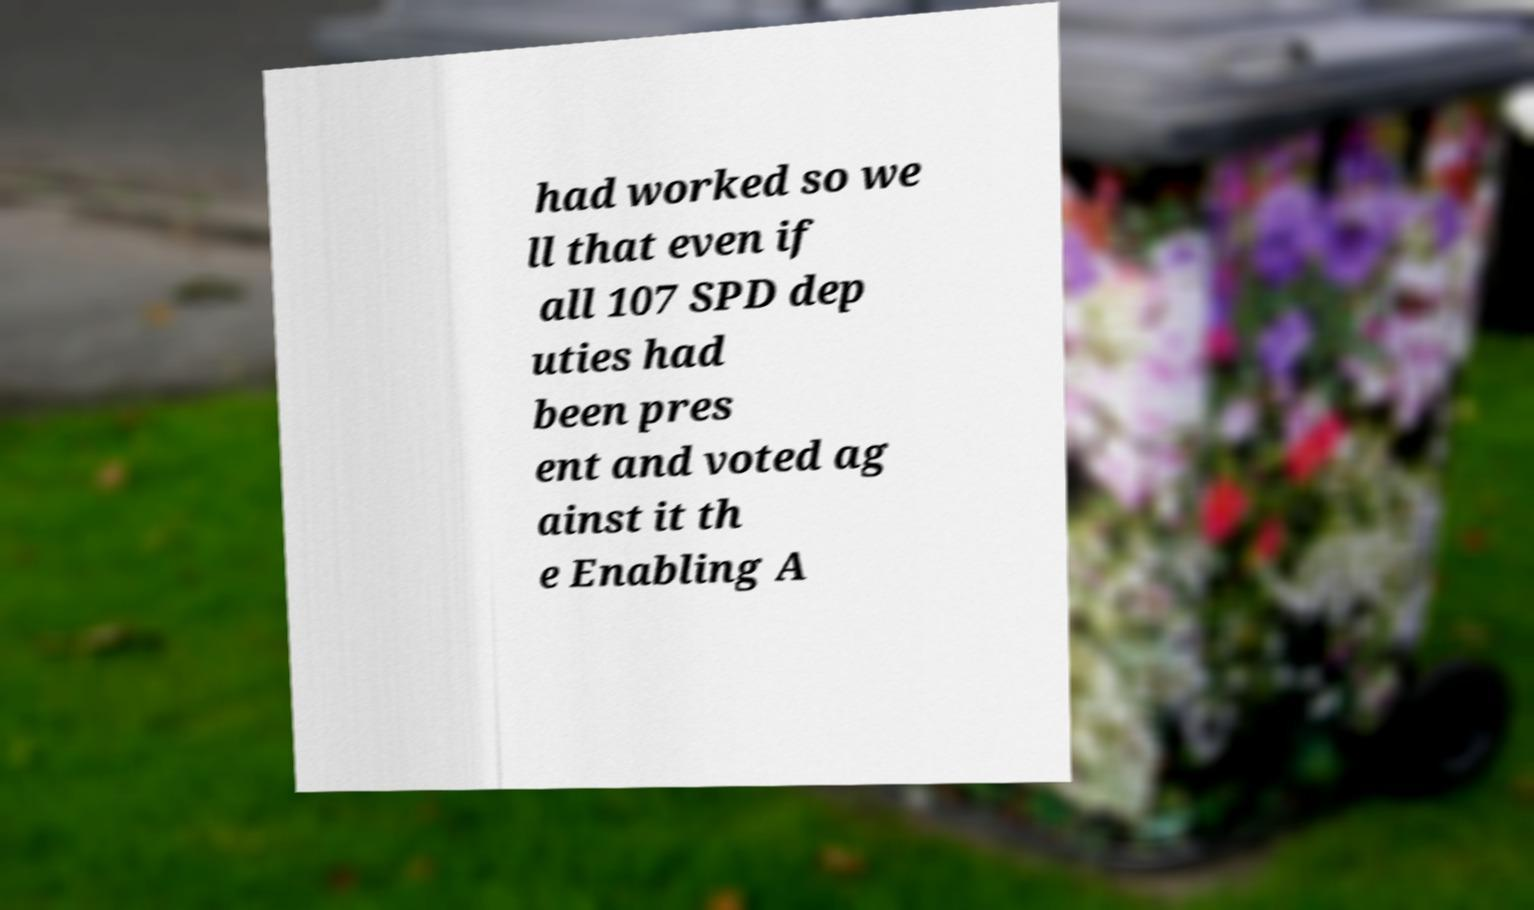Please identify and transcribe the text found in this image. had worked so we ll that even if all 107 SPD dep uties had been pres ent and voted ag ainst it th e Enabling A 